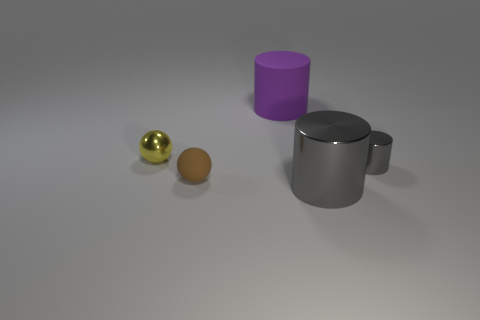There is a small shiny thing that is to the left of the tiny object to the right of the purple cylinder; is there a rubber ball that is in front of it?
Your answer should be compact. Yes. What size is the other metal cylinder that is the same color as the tiny cylinder?
Your answer should be very brief. Large. There is a brown matte sphere; are there any rubber objects to the right of it?
Give a very brief answer. Yes. How many other things are there of the same shape as the big gray object?
Offer a terse response. 2. What is the color of the other object that is the same size as the purple object?
Make the answer very short. Gray. Is the number of gray things in front of the matte ball less than the number of gray objects right of the shiny sphere?
Your response must be concise. Yes. There is a object behind the object left of the small rubber object; what number of small spheres are in front of it?
Provide a succinct answer. 2. There is another metallic thing that is the same shape as the tiny gray shiny thing; what is its size?
Offer a terse response. Large. Are there fewer tiny yellow shiny balls right of the purple thing than small brown balls?
Ensure brevity in your answer.  Yes. Do the yellow thing and the big gray object have the same shape?
Offer a very short reply. No. 